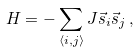<formula> <loc_0><loc_0><loc_500><loc_500>H = - \sum _ { \langle i , j \rangle } J \vec { s } _ { i } \vec { s } _ { j } \, ,</formula> 